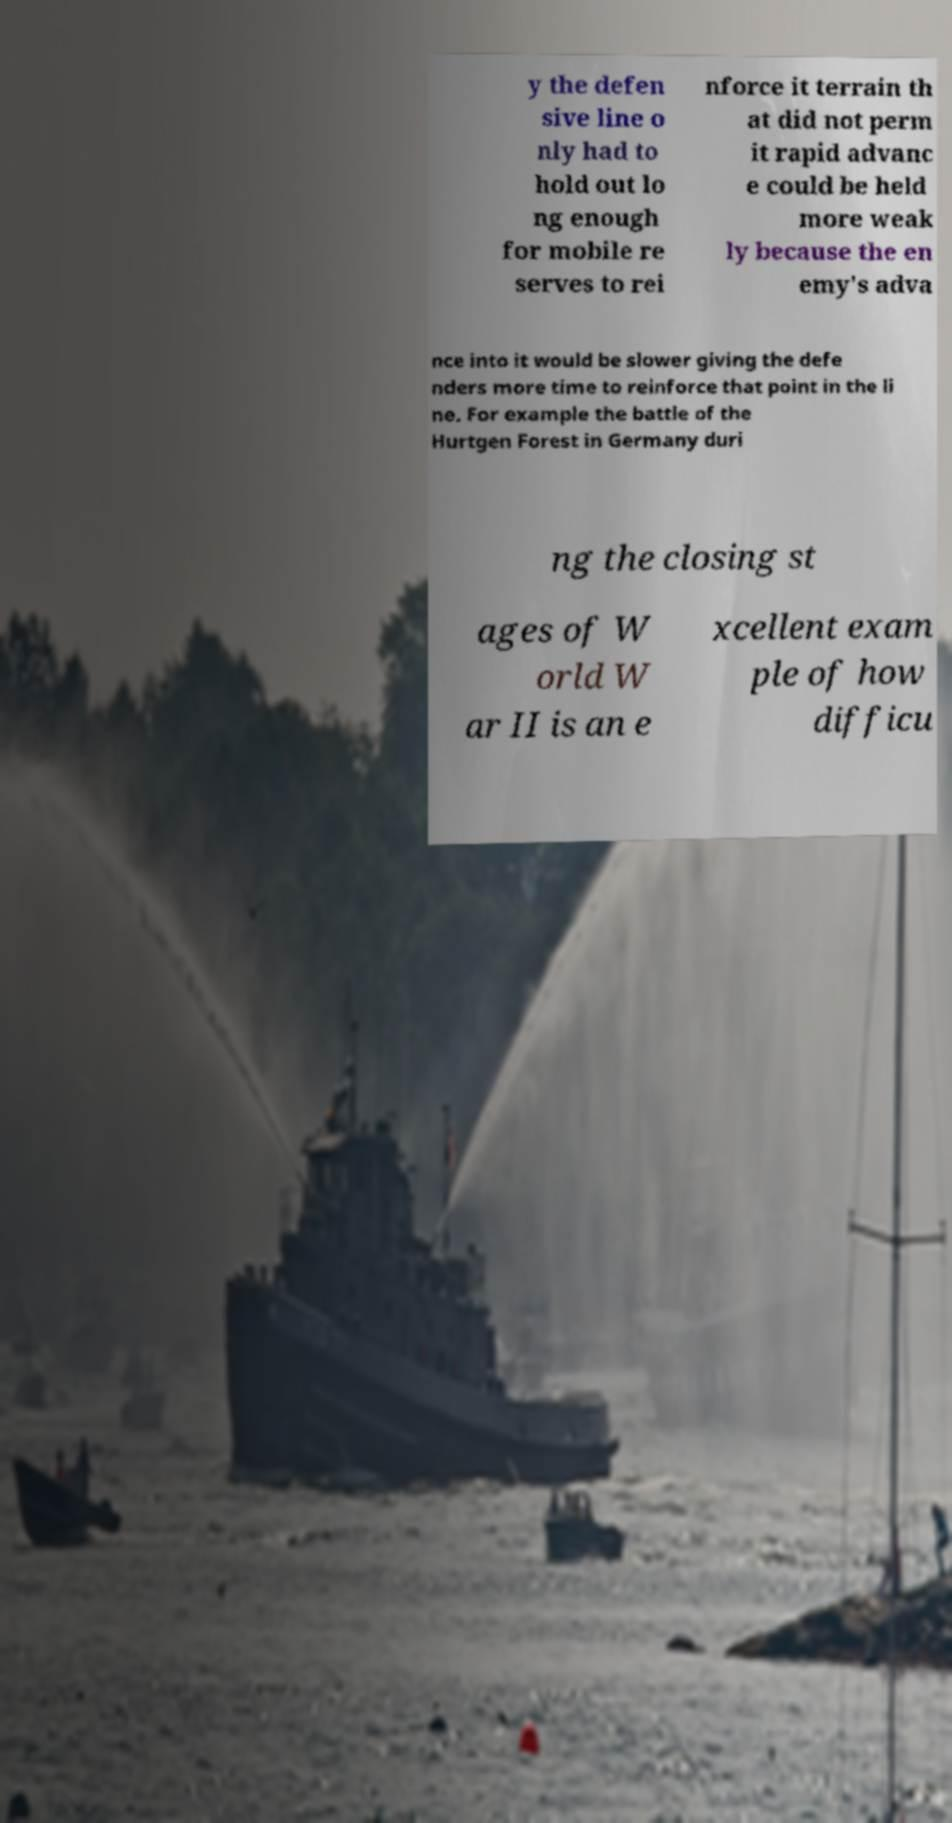Please read and relay the text visible in this image. What does it say? y the defen sive line o nly had to hold out lo ng enough for mobile re serves to rei nforce it terrain th at did not perm it rapid advanc e could be held more weak ly because the en emy's adva nce into it would be slower giving the defe nders more time to reinforce that point in the li ne. For example the battle of the Hurtgen Forest in Germany duri ng the closing st ages of W orld W ar II is an e xcellent exam ple of how difficu 